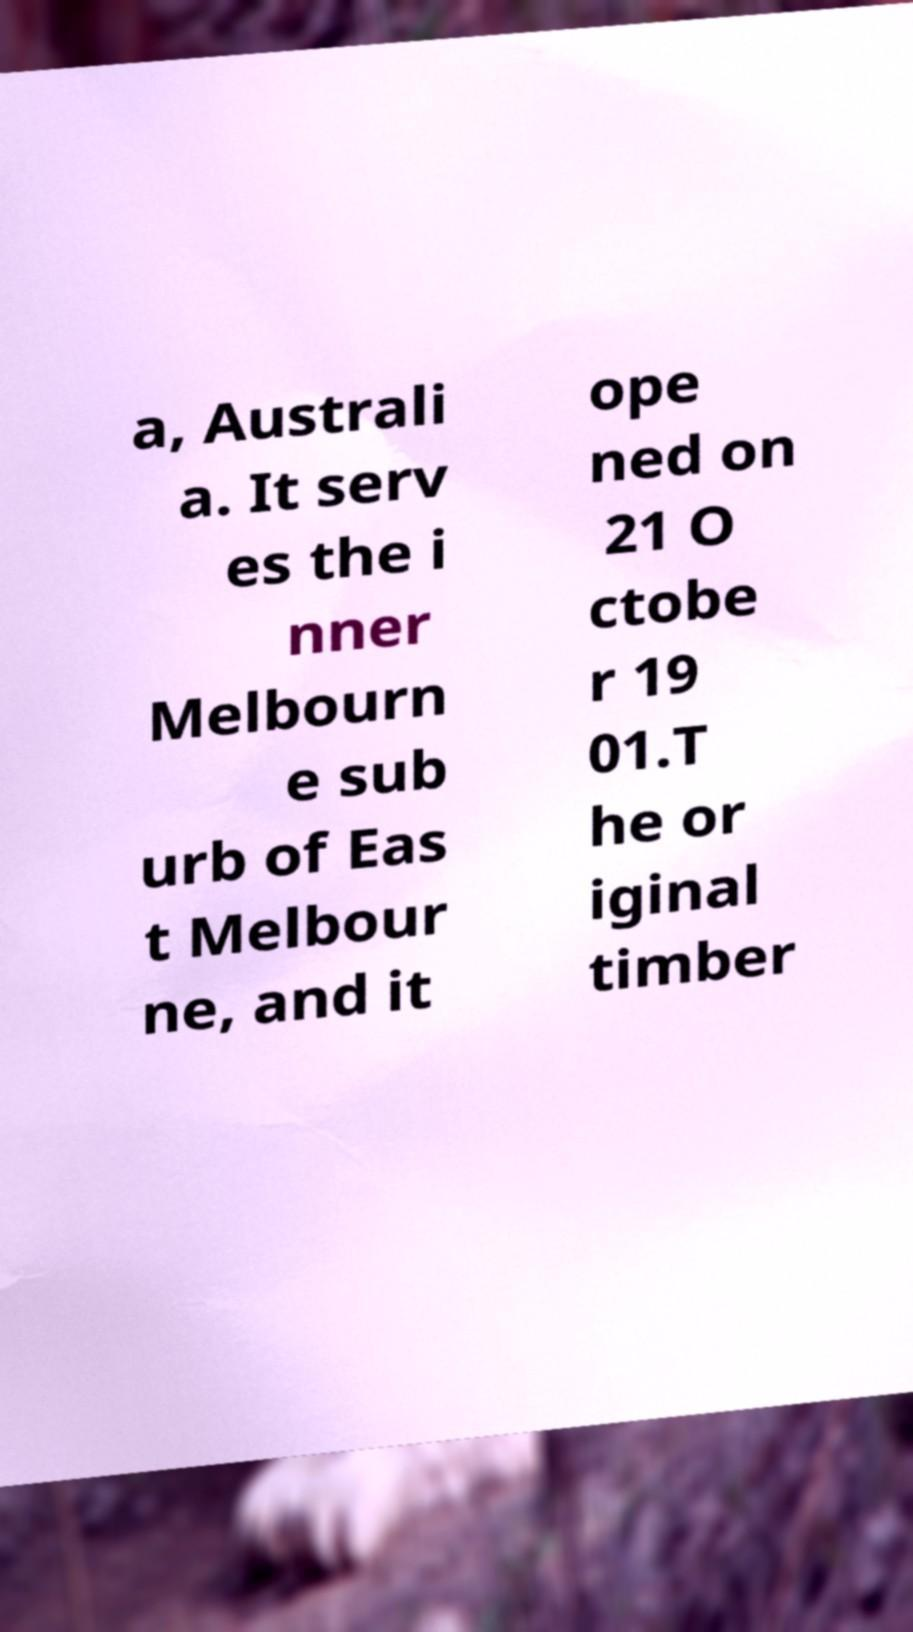Could you extract and type out the text from this image? a, Australi a. It serv es the i nner Melbourn e sub urb of Eas t Melbour ne, and it ope ned on 21 O ctobe r 19 01.T he or iginal timber 